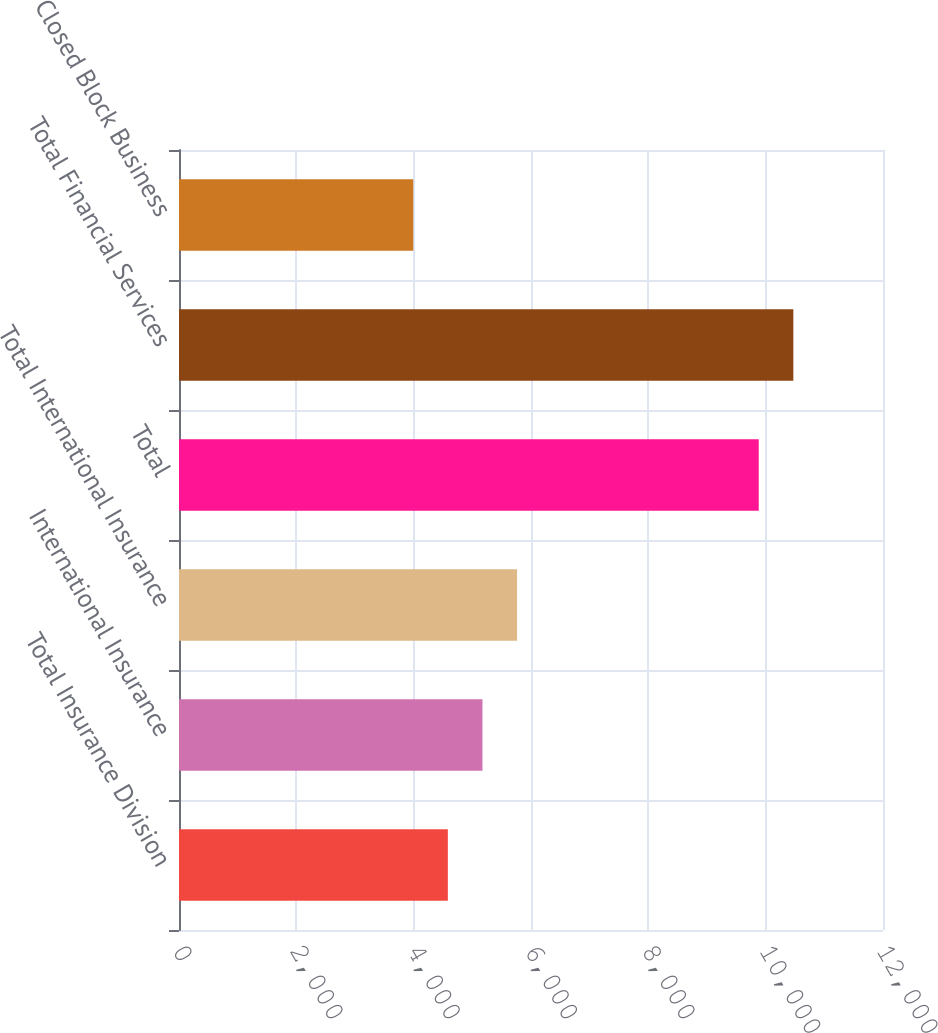Convert chart to OTSL. <chart><loc_0><loc_0><loc_500><loc_500><bar_chart><fcel>Total Insurance Division<fcel>International Insurance<fcel>Total International Insurance<fcel>Total<fcel>Total Financial Services<fcel>Closed Block Business<nl><fcel>4582.7<fcel>5172.4<fcel>5762.1<fcel>9882<fcel>10471.7<fcel>3993<nl></chart> 